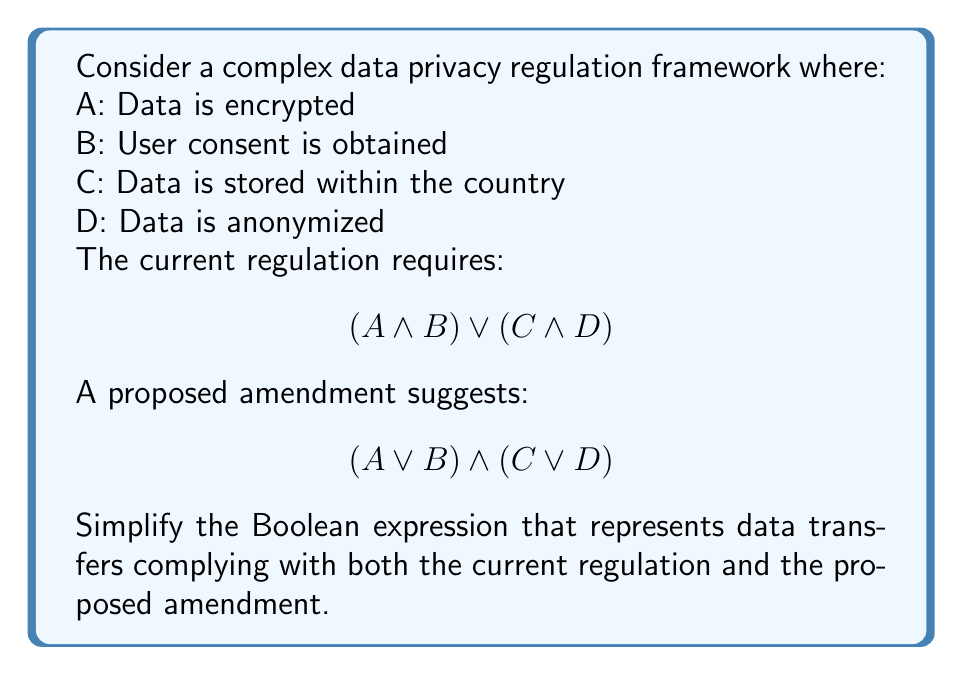Help me with this question. To solve this problem, we need to combine the two expressions using the AND operator (∧) and then simplify the resulting expression. Let's go through this step-by-step:

1) Combine the expressions:
   $$((A \land B) \lor (C \land D)) \land ((A \lor B) \land (C \lor D))$$

2) Apply the distributive law to expand the expression:
   $$((A \land B) \land (A \lor B) \land (C \lor D)) \lor ((C \land D) \land (A \lor B) \land (C \lor D))$$

3) Simplify $(A \land B) \land (A \lor B)$:
   This always equals $(A \land B)$ because if both A and B are true, $(A \lor B)$ is also true.

4) Simplify $(C \land D) \land (C \lor D)$:
   This always equals $(C \land D)$ for the same reason as step 3.

5) After these simplifications, our expression becomes:
   $$(A \land B \land (C \lor D)) \lor (C \land D \land (A \lor B))$$

6) Apply the distributive law again:
   $$(A \land B \land C) \lor (A \land B \land D) \lor (A \land C \land D) \lor (B \land C \land D)$$

This is the simplified Boolean expression representing data transfers that comply with both the current regulation and the proposed amendment.
Answer: $$(A \land B \land C) \lor (A \land B \land D) \lor (A \land C \land D) \lor (B \land C \land D)$$ 